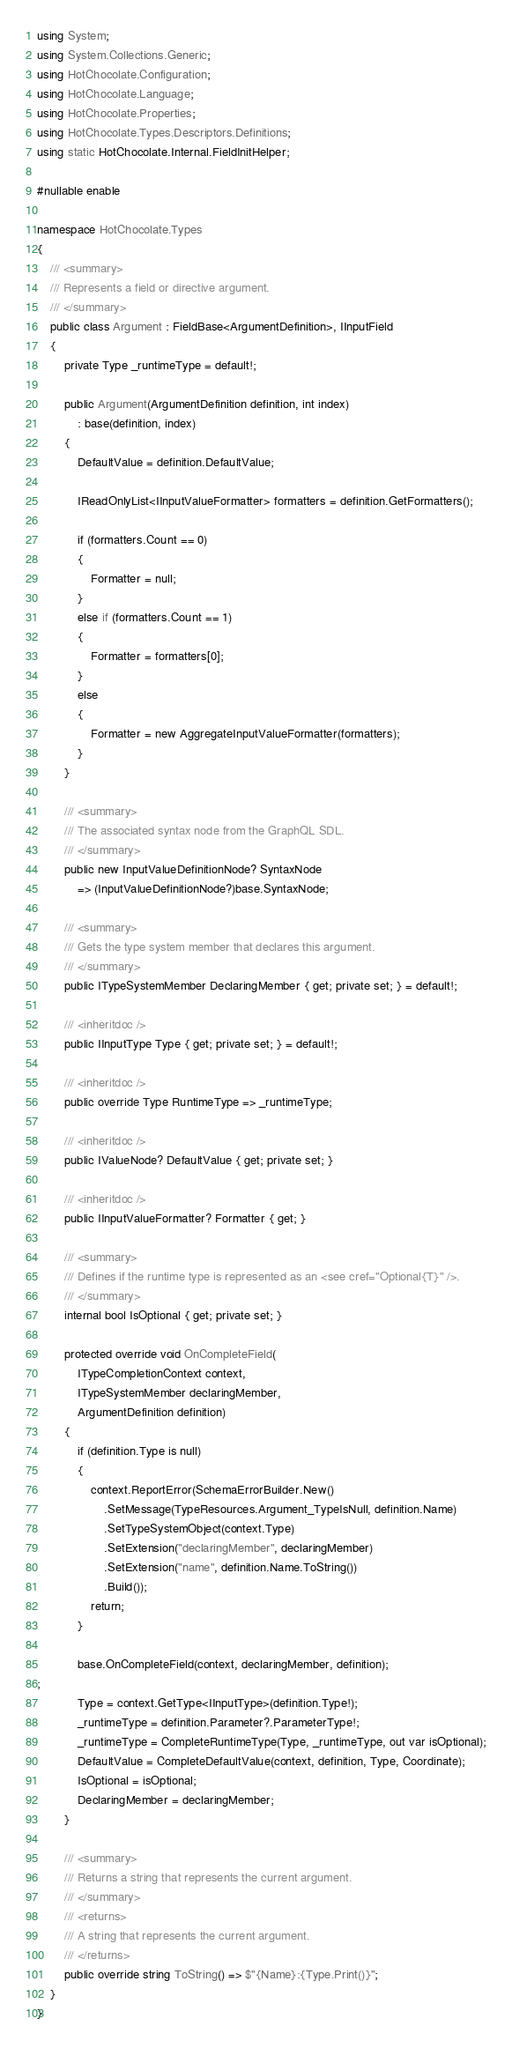<code> <loc_0><loc_0><loc_500><loc_500><_C#_>using System;
using System.Collections.Generic;
using HotChocolate.Configuration;
using HotChocolate.Language;
using HotChocolate.Properties;
using HotChocolate.Types.Descriptors.Definitions;
using static HotChocolate.Internal.FieldInitHelper;

#nullable enable

namespace HotChocolate.Types
{
    /// <summary>
    /// Represents a field or directive argument.
    /// </summary>
    public class Argument : FieldBase<ArgumentDefinition>, IInputField
    {
        private Type _runtimeType = default!;

        public Argument(ArgumentDefinition definition, int index)
            : base(definition, index)
        {
            DefaultValue = definition.DefaultValue;

            IReadOnlyList<IInputValueFormatter> formatters = definition.GetFormatters();

            if (formatters.Count == 0)
            {
                Formatter = null;
            }
            else if (formatters.Count == 1)
            {
                Formatter = formatters[0];
            }
            else
            {
                Formatter = new AggregateInputValueFormatter(formatters);
            }
        }

        /// <summary>
        /// The associated syntax node from the GraphQL SDL.
        /// </summary>
        public new InputValueDefinitionNode? SyntaxNode
            => (InputValueDefinitionNode?)base.SyntaxNode;

        /// <summary>
        /// Gets the type system member that declares this argument.
        /// </summary>
        public ITypeSystemMember DeclaringMember { get; private set; } = default!;

        /// <inheritdoc />
        public IInputType Type { get; private set; } = default!;

        /// <inheritdoc />
        public override Type RuntimeType => _runtimeType;

        /// <inheritdoc />
        public IValueNode? DefaultValue { get; private set; }

        /// <inheritdoc />
        public IInputValueFormatter? Formatter { get; }

        /// <summary>
        /// Defines if the runtime type is represented as an <see cref="Optional{T}" />.
        /// </summary>
        internal bool IsOptional { get; private set; }

        protected override void OnCompleteField(
            ITypeCompletionContext context,
            ITypeSystemMember declaringMember,
            ArgumentDefinition definition)
        {
            if (definition.Type is null)
            {
                context.ReportError(SchemaErrorBuilder.New()
                    .SetMessage(TypeResources.Argument_TypeIsNull, definition.Name)
                    .SetTypeSystemObject(context.Type)
                    .SetExtension("declaringMember", declaringMember)
                    .SetExtension("name", definition.Name.ToString())
                    .Build());
                return;
            }

            base.OnCompleteField(context, declaringMember, definition);
;
            Type = context.GetType<IInputType>(definition.Type!);
            _runtimeType = definition.Parameter?.ParameterType!;
            _runtimeType = CompleteRuntimeType(Type, _runtimeType, out var isOptional);
            DefaultValue = CompleteDefaultValue(context, definition, Type, Coordinate);
            IsOptional = isOptional;
            DeclaringMember = declaringMember;
        }

        /// <summary>
        /// Returns a string that represents the current argument.
        /// </summary>
        /// <returns>
        /// A string that represents the current argument.
        /// </returns>
        public override string ToString() => $"{Name}:{Type.Print()}";
    }
}
</code> 